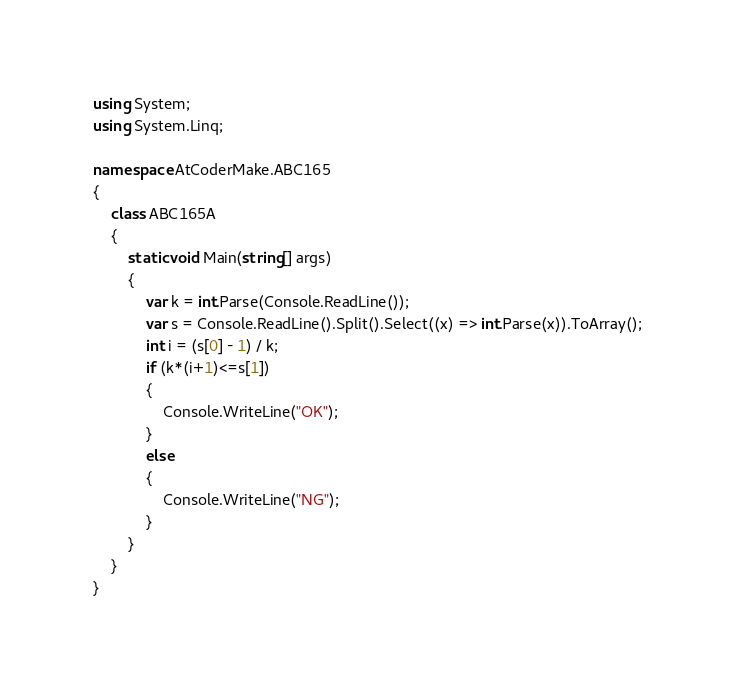Convert code to text. <code><loc_0><loc_0><loc_500><loc_500><_C#_>using System;
using System.Linq;

namespace AtCoderMake.ABC165
{
    class ABC165A
    {
        static void Main(string[] args)
        {
            var k = int.Parse(Console.ReadLine());
            var s = Console.ReadLine().Split().Select((x) => int.Parse(x)).ToArray();
            int i = (s[0] - 1) / k;
            if (k*(i+1)<=s[1])
            {
                Console.WriteLine("OK");
            }
            else
            {
                Console.WriteLine("NG");
            }
        }
    }
}
</code> 